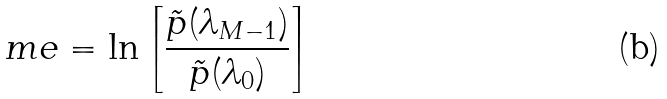<formula> <loc_0><loc_0><loc_500><loc_500>\ m e = \ln \left [ \frac { \tilde { p } ( \lambda _ { M - 1 } ) } { \tilde { p } ( \lambda _ { 0 } ) } \right ]</formula> 